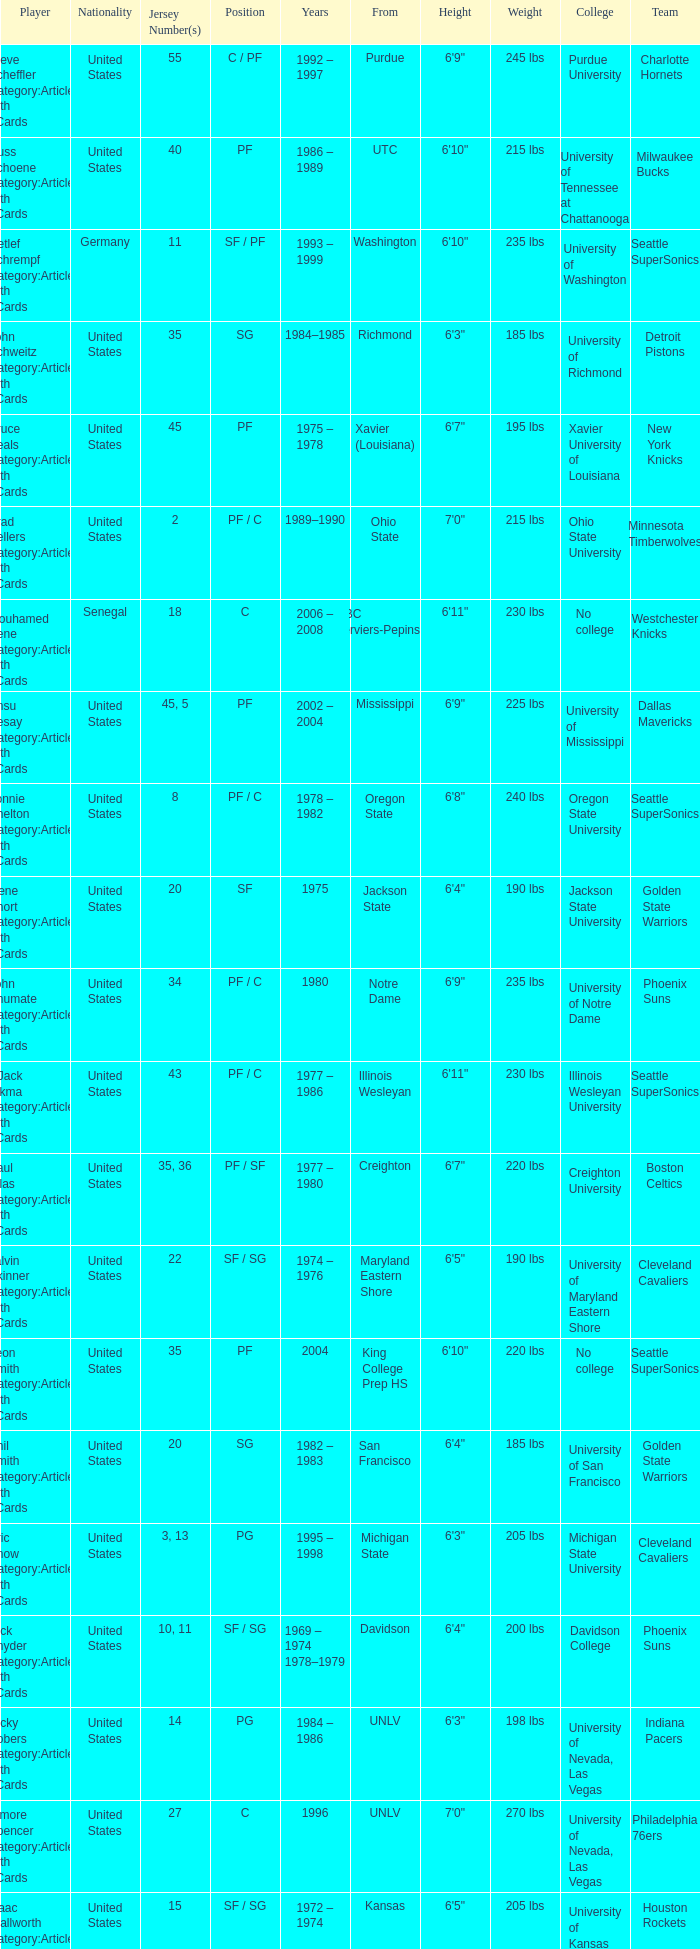Who wears the jersey number 20 and has the position of SG? Phil Smith Category:Articles with hCards, Jon Sundvold Category:Articles with hCards. 